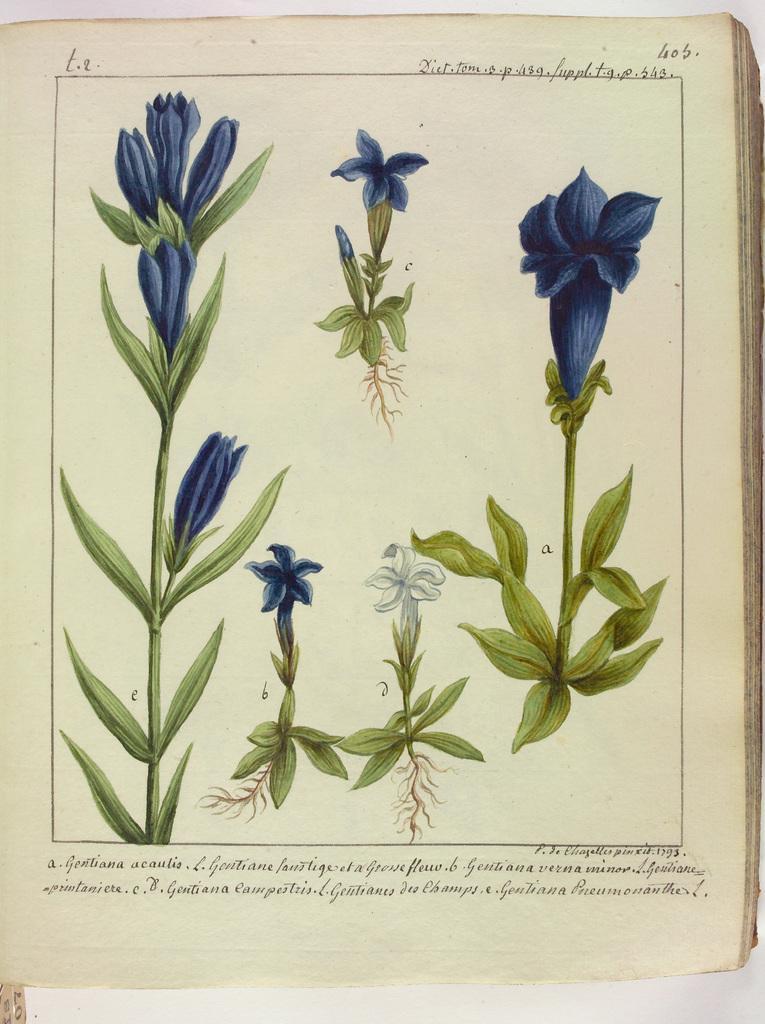How would you summarize this image in a sentence or two? In this image we can see a book, on the book we can see some plants with flowers and text. 